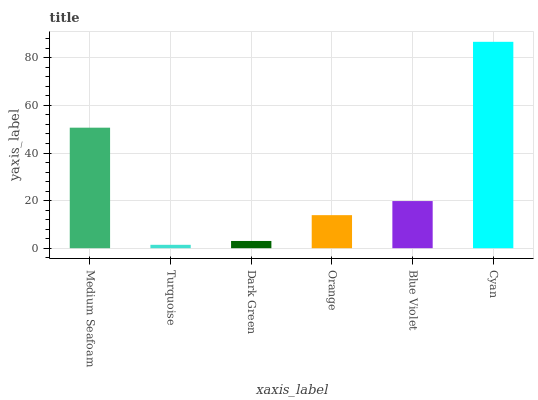Is Dark Green the minimum?
Answer yes or no. No. Is Dark Green the maximum?
Answer yes or no. No. Is Dark Green greater than Turquoise?
Answer yes or no. Yes. Is Turquoise less than Dark Green?
Answer yes or no. Yes. Is Turquoise greater than Dark Green?
Answer yes or no. No. Is Dark Green less than Turquoise?
Answer yes or no. No. Is Blue Violet the high median?
Answer yes or no. Yes. Is Orange the low median?
Answer yes or no. Yes. Is Orange the high median?
Answer yes or no. No. Is Blue Violet the low median?
Answer yes or no. No. 